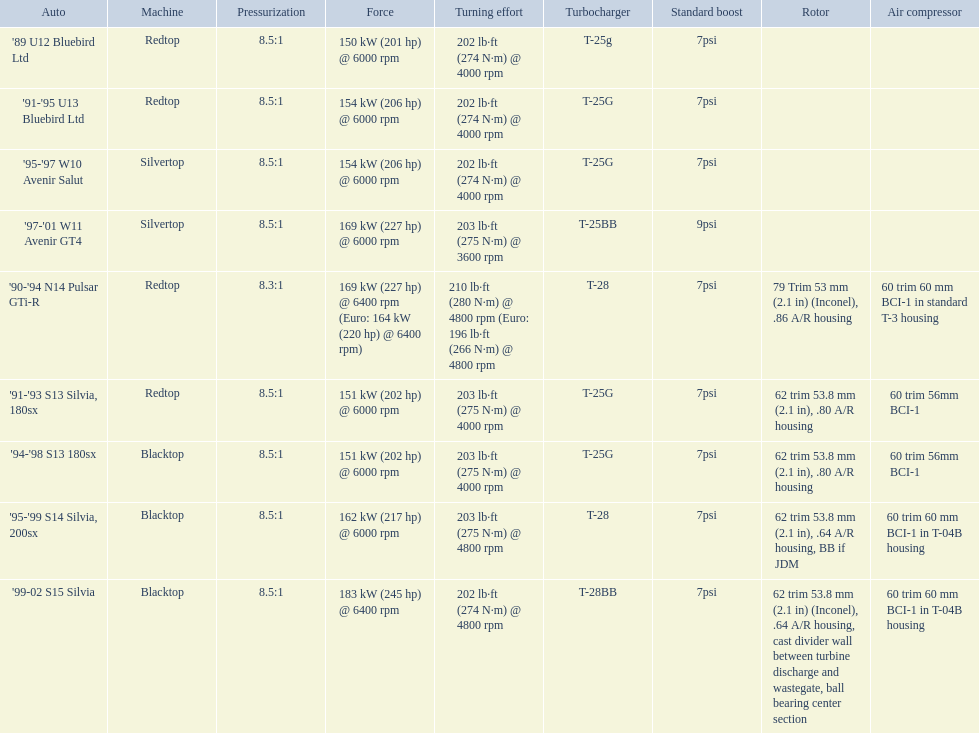What are all of the nissan cars? '89 U12 Bluebird Ltd, '91-'95 U13 Bluebird Ltd, '95-'97 W10 Avenir Salut, '97-'01 W11 Avenir GT4, '90-'94 N14 Pulsar GTi-R, '91-'93 S13 Silvia, 180sx, '94-'98 S13 180sx, '95-'99 S14 Silvia, 200sx, '99-02 S15 Silvia. Of these cars, which one is a '90-'94 n14 pulsar gti-r? '90-'94 N14 Pulsar GTi-R. What is the compression of this car? 8.3:1. 